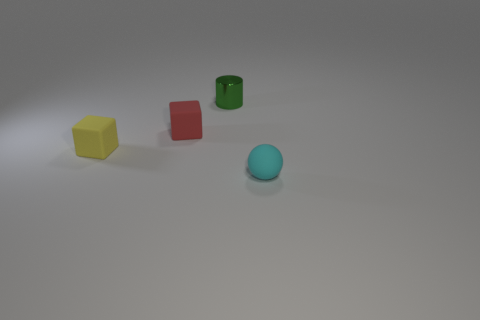Add 3 shiny cylinders. How many objects exist? 7 Subtract all spheres. How many objects are left? 3 Subtract 1 spheres. How many spheres are left? 0 Add 2 tiny yellow rubber things. How many tiny yellow rubber things are left? 3 Add 4 metal cylinders. How many metal cylinders exist? 5 Subtract 1 red cubes. How many objects are left? 3 Subtract all yellow cubes. Subtract all cyan balls. How many cubes are left? 1 Subtract all yellow spheres. How many brown cubes are left? 0 Subtract all tiny objects. Subtract all big rubber spheres. How many objects are left? 0 